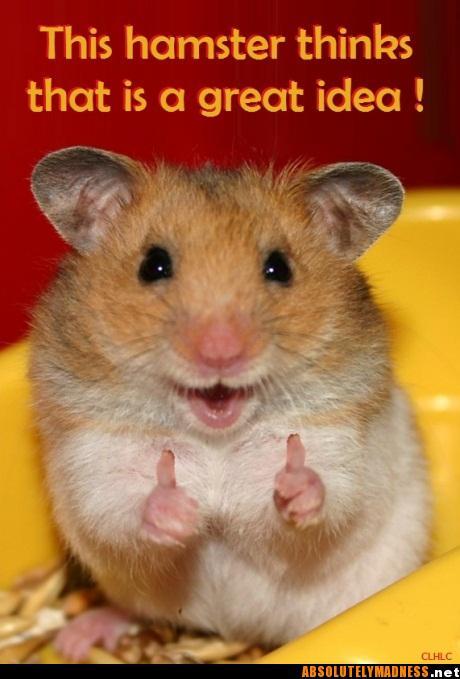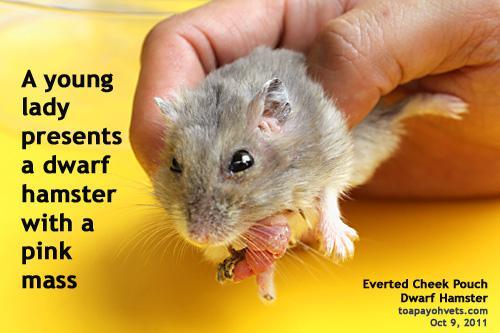The first image is the image on the left, the second image is the image on the right. Analyze the images presented: Is the assertion "An image includes an upright hamster grasping a piece of food nearly as big as its head." valid? Answer yes or no. No. 